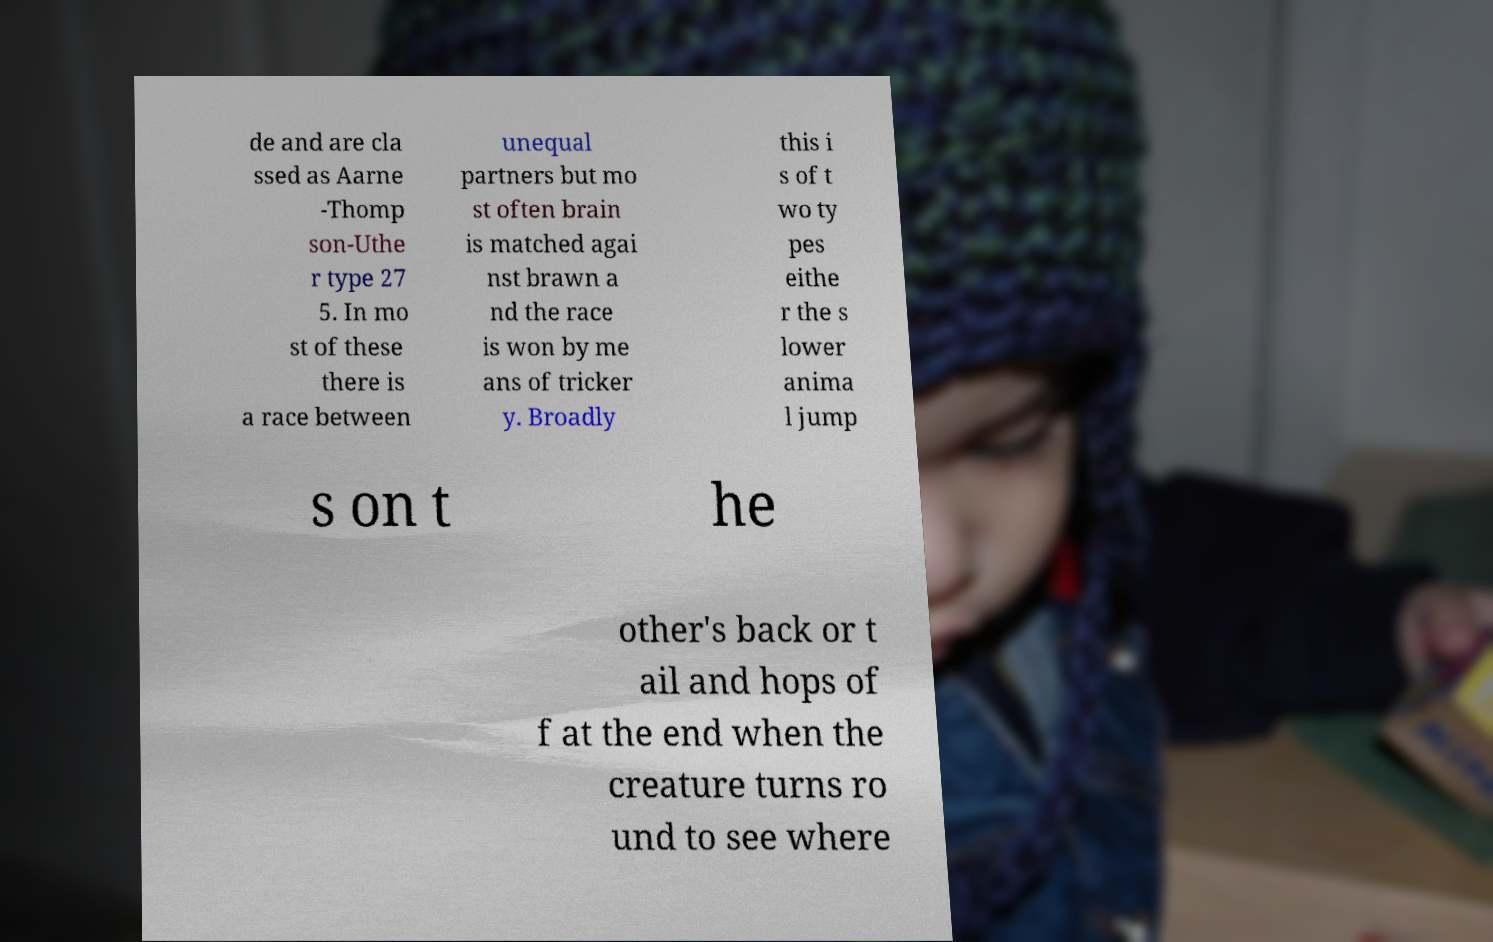Can you read and provide the text displayed in the image?This photo seems to have some interesting text. Can you extract and type it out for me? de and are cla ssed as Aarne -Thomp son-Uthe r type 27 5. In mo st of these there is a race between unequal partners but mo st often brain is matched agai nst brawn a nd the race is won by me ans of tricker y. Broadly this i s of t wo ty pes eithe r the s lower anima l jump s on t he other's back or t ail and hops of f at the end when the creature turns ro und to see where 